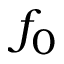<formula> <loc_0><loc_0><loc_500><loc_500>f _ { 0 }</formula> 